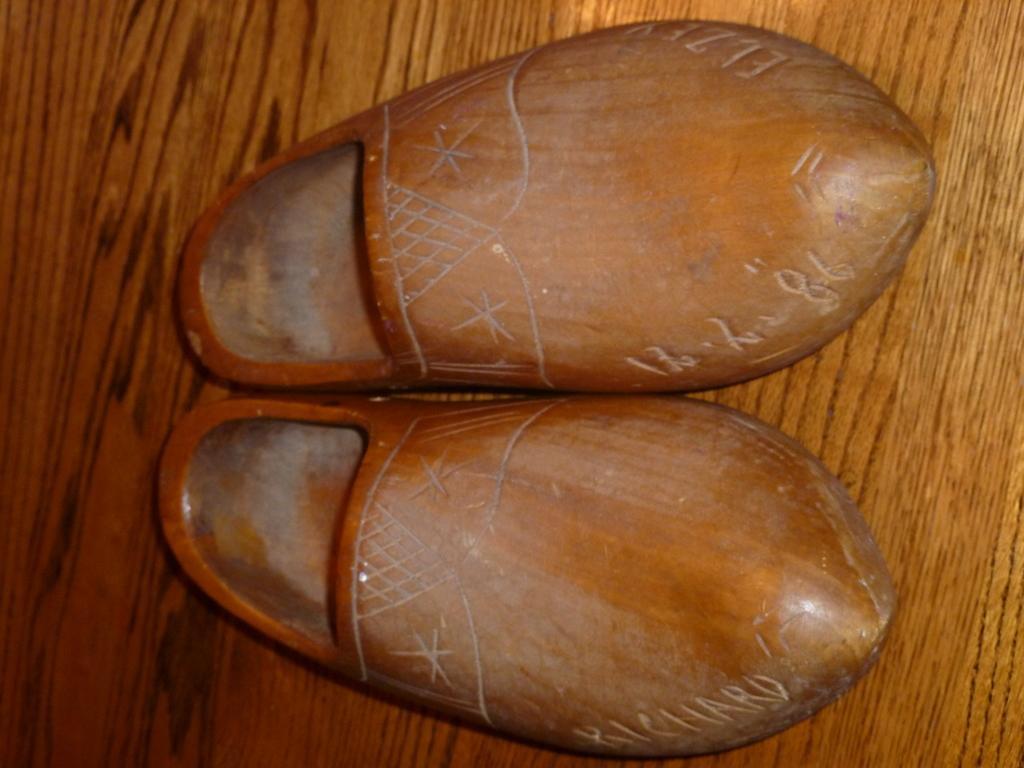In one or two sentences, can you explain what this image depicts? In the picture I can see shoes and some text. 